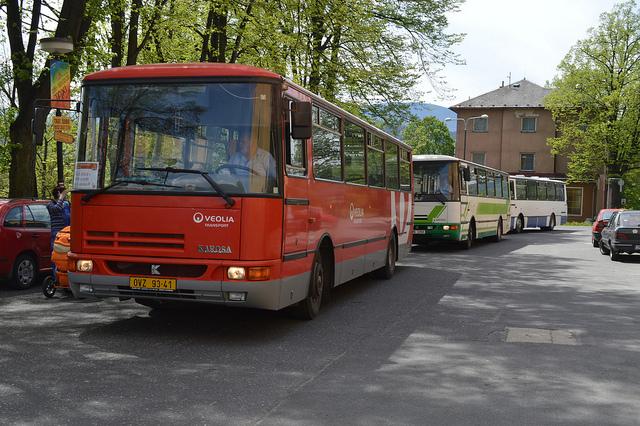Is there a bus on the wrong side of the road?
Write a very short answer. No. Are these good modes of transportation for groups of people?
Answer briefly. Yes. Are these buses driving on dirt roads?
Concise answer only. No. How many busses are shown?
Answer briefly. 3. 